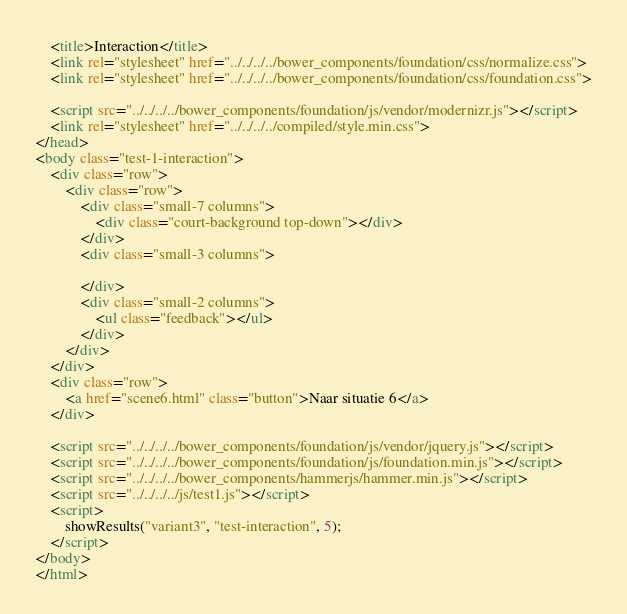Convert code to text. <code><loc_0><loc_0><loc_500><loc_500><_HTML_>    <title>Interaction</title>
    <link rel="stylesheet" href="../../../../bower_components/foundation/css/normalize.css">
    <link rel="stylesheet" href="../../../../bower_components/foundation/css/foundation.css">
    
    <script src="../../../../bower_components/foundation/js/vendor/modernizr.js"></script>
    <link rel="stylesheet" href="../../../../compiled/style.min.css">
</head>
<body class="test-1-interaction">
    <div class="row">
        <div class="row">
            <div class="small-7 columns">
                <div class="court-background top-down"></div>
            </div>
            <div class="small-3 columns">
                
            </div>
            <div class="small-2 columns">
                <ul class="feedback"></ul>
            </div>
        </div>
    </div>
    <div class="row">
        <a href="scene6.html" class="button">Naar situatie 6</a>
    </div>
    
    <script src="../../../../bower_components/foundation/js/vendor/jquery.js"></script>
    <script src="../../../../bower_components/foundation/js/foundation.min.js"></script>
    <script src="../../../../bower_components/hammerjs/hammer.min.js"></script>
    <script src="../../../../js/test1.js"></script>
    <script>
        showResults("variant3", "test-interaction", 5);
    </script>
</body>
</html>
</code> 